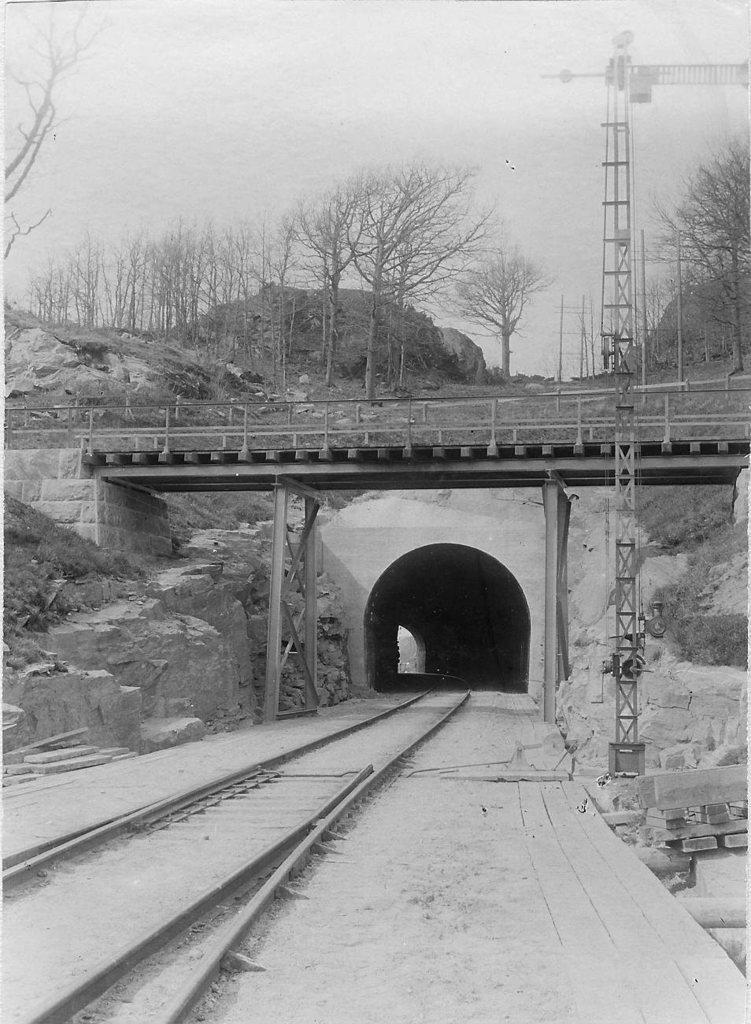Please provide a concise description of this image. In this image I can see a railway track. At the top I can see a bridge, the trees and the sky. 